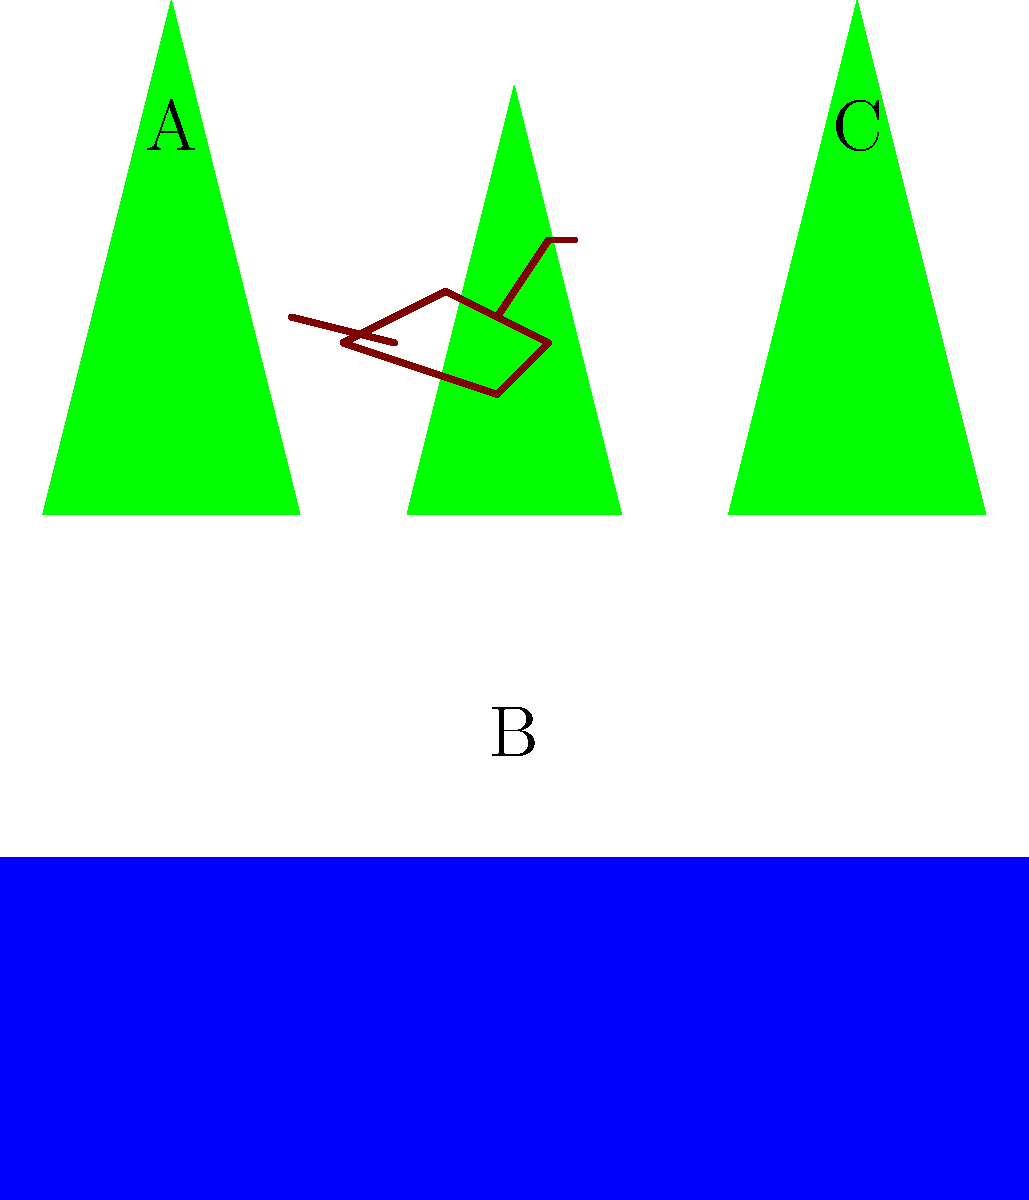In the simplified ecosystem illustration above, which area (A, B, or C) would most likely be the preferred habitat for a large herbivorous sauropod dinosaur? To determine the most suitable habitat for a large herbivorous sauropod dinosaur, we need to consider their characteristics and requirements:

1. Diet: Sauropods were herbivores, meaning they fed exclusively on plants.
2. Size: They were among the largest land animals ever, requiring ample space and food sources.
3. Water needs: Like most large animals, they would need access to water.

Now, let's analyze each area in the illustration:

A: This area shows tall trees, indicating a forested region. While there are plants available, the density of trees might make it difficult for a large sauropod to move around easily.

B: This area is depicted as a body of water. While sauropods would need to drink, they were not aquatic and wouldn't live primarily in water.

C: This area shows a mix of open space and trees. It provides:
   - Accessible vegetation for feeding
   - Open areas for easy movement
   - Proximity to water for drinking

Given these factors, area C would be the most suitable habitat for a large herbivorous sauropod. It offers a balance of food sources, space to move, and access to water, which are all crucial for the survival and comfort of these massive dinosaurs.
Answer: C 